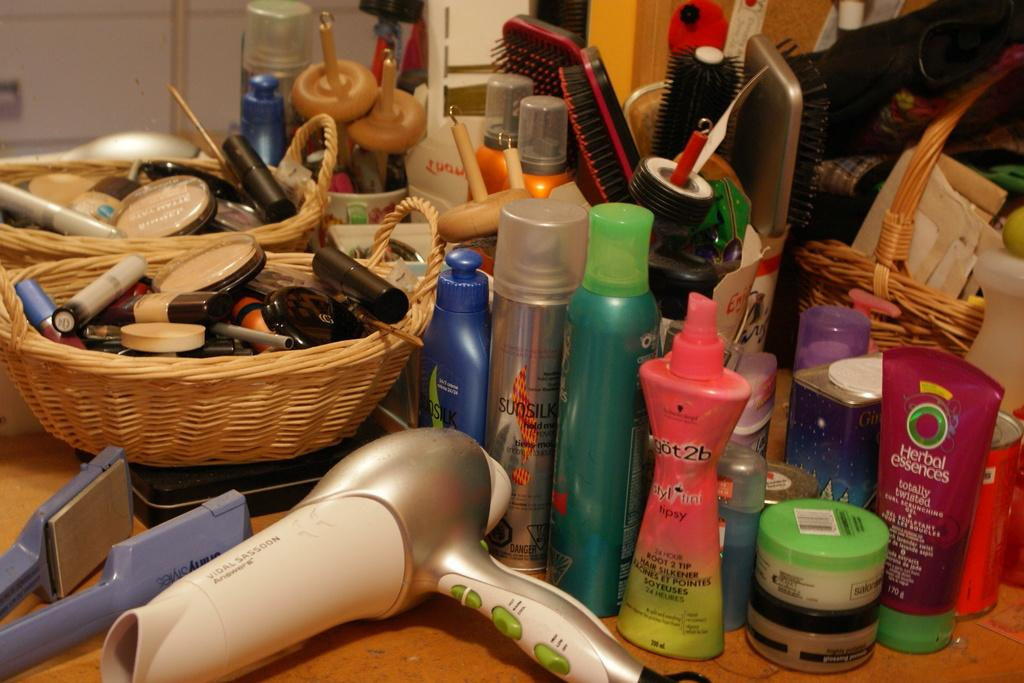What type of products are visible in the image? There are perfumes, combs, and creams in the image. What personal care item can be seen in the image? There is a hair dryer in the image. Can you describe the different types of products in the image? The image contains perfumes, which are used for fragrance, combs, which are used for grooming hair, and creams, which are used for moisturizing or treating skin. How many babies are present in the image? There are no babies present in the image; it features personal care products such as perfumes, combs, creams, and a hair dryer. 